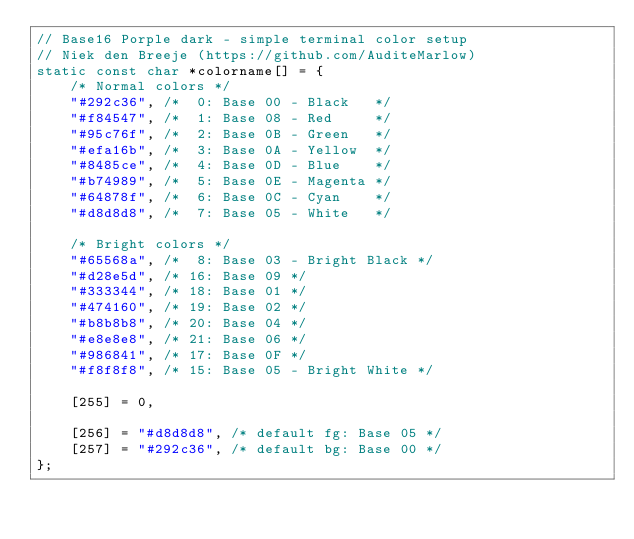<code> <loc_0><loc_0><loc_500><loc_500><_C_>// Base16 Porple dark - simple terminal color setup
// Niek den Breeje (https://github.com/AuditeMarlow)
static const char *colorname[] = {
	/* Normal colors */
	"#292c36", /*  0: Base 00 - Black   */
	"#f84547", /*  1: Base 08 - Red     */
	"#95c76f", /*  2: Base 0B - Green   */
	"#efa16b", /*  3: Base 0A - Yellow  */
	"#8485ce", /*  4: Base 0D - Blue    */
	"#b74989", /*  5: Base 0E - Magenta */
	"#64878f", /*  6: Base 0C - Cyan    */
	"#d8d8d8", /*  7: Base 05 - White   */

	/* Bright colors */
	"#65568a", /*  8: Base 03 - Bright Black */
	"#d28e5d", /* 16: Base 09 */
	"#333344", /* 18: Base 01 */
	"#474160", /* 19: Base 02 */
	"#b8b8b8", /* 20: Base 04 */
	"#e8e8e8", /* 21: Base 06 */
	"#986841", /* 17: Base 0F */
	"#f8f8f8", /* 15: Base 05 - Bright White */

	[255] = 0,

	[256] = "#d8d8d8", /* default fg: Base 05 */
	[257] = "#292c36", /* default bg: Base 00 */
};
</code> 